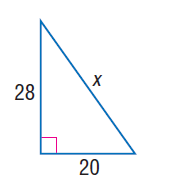Answer the mathemtical geometry problem and directly provide the correct option letter.
Question: Find x.
Choices: A: 8 \sqrt { 6 } B: 20 C: 28 D: 4 \sqrt { 74 } D 